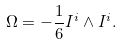<formula> <loc_0><loc_0><loc_500><loc_500>\Omega = - \frac { 1 } { 6 } I ^ { i } \wedge I ^ { i } .</formula> 